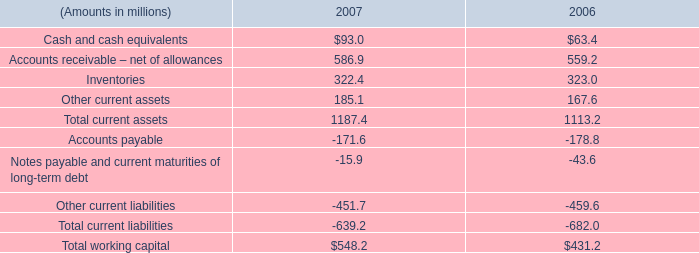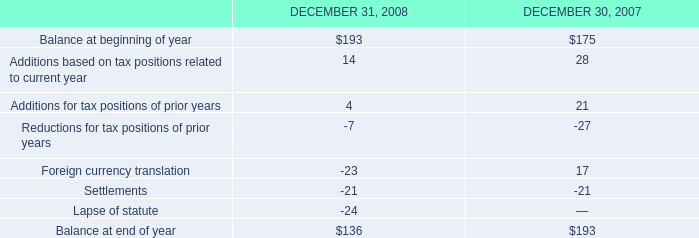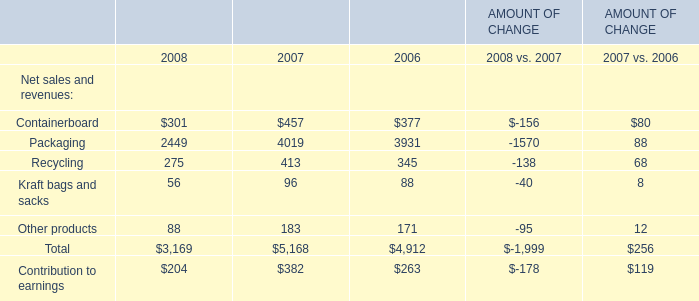What was the average value ofPackagingRecyclingKraft bags and sacks in 2008? 
Computations: (((2449 + 275) + 56) / 3)
Answer: 926.66667. 